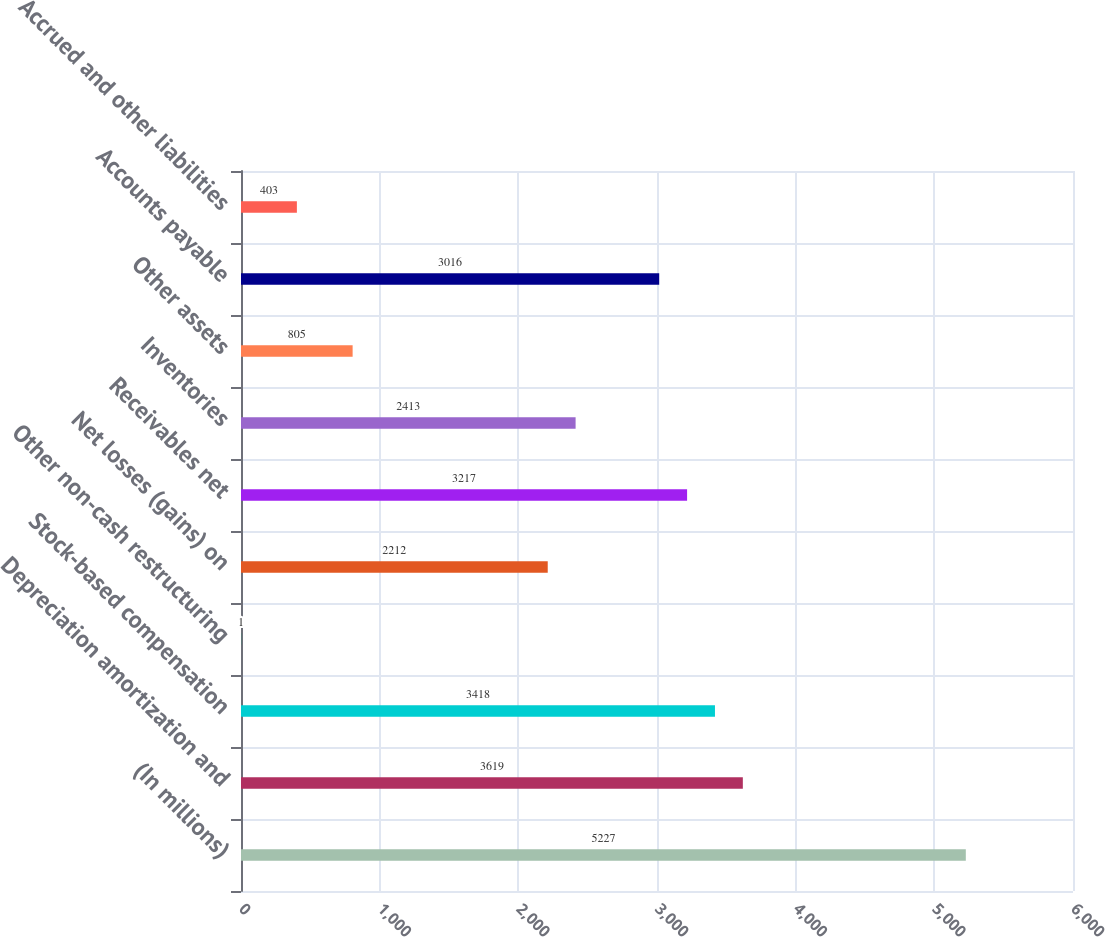<chart> <loc_0><loc_0><loc_500><loc_500><bar_chart><fcel>(In millions)<fcel>Depreciation amortization and<fcel>Stock-based compensation<fcel>Other non-cash restructuring<fcel>Net losses (gains) on<fcel>Receivables net<fcel>Inventories<fcel>Other assets<fcel>Accounts payable<fcel>Accrued and other liabilities<nl><fcel>5227<fcel>3619<fcel>3418<fcel>1<fcel>2212<fcel>3217<fcel>2413<fcel>805<fcel>3016<fcel>403<nl></chart> 